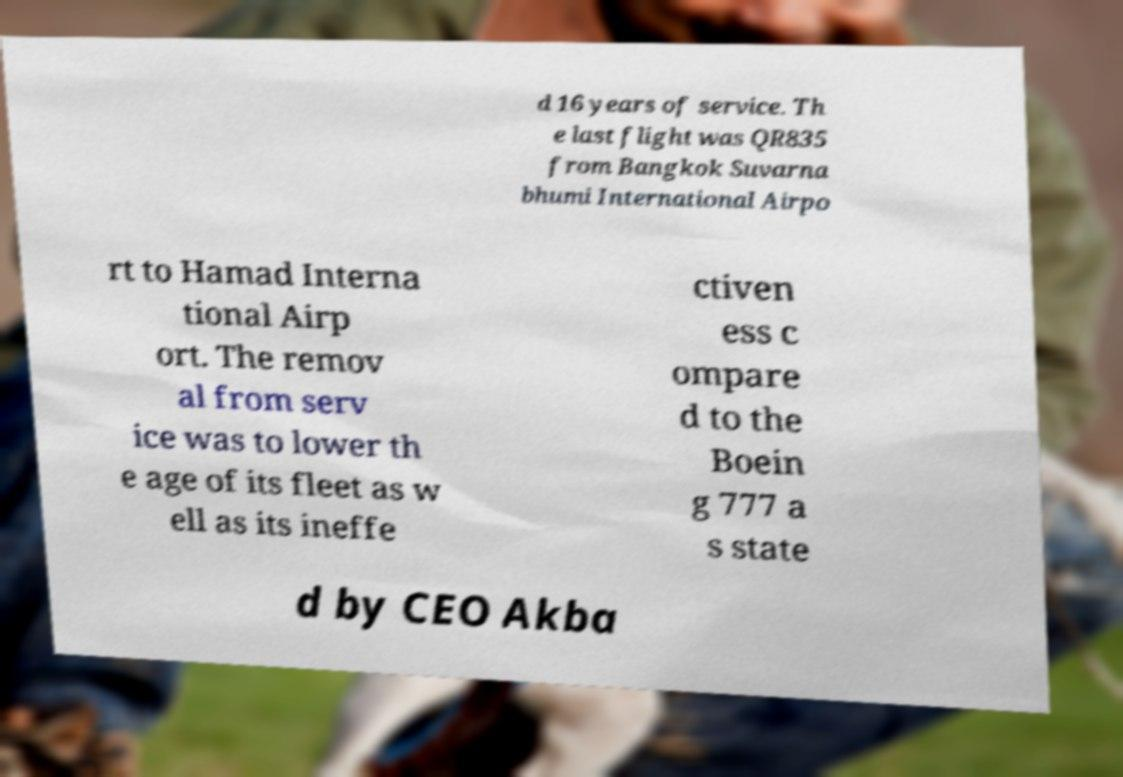Please read and relay the text visible in this image. What does it say? d 16 years of service. Th e last flight was QR835 from Bangkok Suvarna bhumi International Airpo rt to Hamad Interna tional Airp ort. The remov al from serv ice was to lower th e age of its fleet as w ell as its ineffe ctiven ess c ompare d to the Boein g 777 a s state d by CEO Akba 